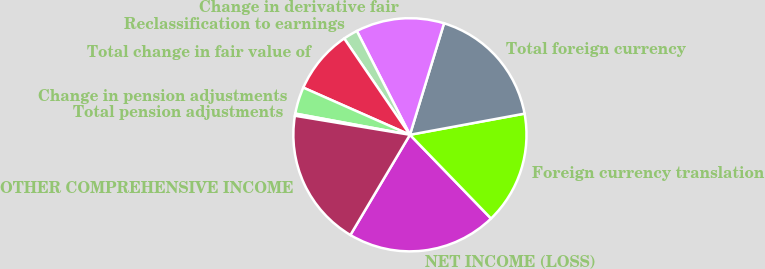Convert chart. <chart><loc_0><loc_0><loc_500><loc_500><pie_chart><fcel>NET INCOME (LOSS)<fcel>Foreign currency translation<fcel>Total foreign currency<fcel>Change in derivative fair<fcel>Reclassification to earnings<fcel>Total change in fair value of<fcel>Change in pension adjustments<fcel>Total pension adjustments<fcel>OTHER COMPREHENSIVE INCOME<nl><fcel>20.78%<fcel>15.66%<fcel>17.37%<fcel>12.25%<fcel>2.01%<fcel>8.84%<fcel>3.72%<fcel>0.3%<fcel>19.08%<nl></chart> 